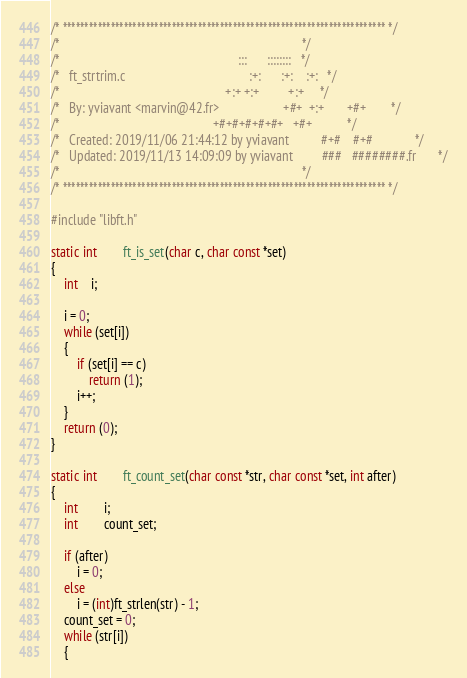<code> <loc_0><loc_0><loc_500><loc_500><_C_>/* ************************************************************************** */
/*                                                                            */
/*                                                        :::      ::::::::   */
/*   ft_strtrim.c                                       :+:      :+:    :+:   */
/*                                                    +:+ +:+         +:+     */
/*   By: yviavant <marvin@42.fr>                    +#+  +:+       +#+        */
/*                                                +#+#+#+#+#+   +#+           */
/*   Created: 2019/11/06 21:44:12 by yviavant          #+#    #+#             */
/*   Updated: 2019/11/13 14:09:09 by yviavant         ###   ########.fr       */
/*                                                                            */
/* ************************************************************************** */

#include "libft.h"

static int		ft_is_set(char c, char const *set)
{
	int	i;

	i = 0;
	while (set[i])
	{
		if (set[i] == c)
			return (1);
		i++;
	}
	return (0);
}

static int		ft_count_set(char const *str, char const *set, int after)
{
	int		i;
	int		count_set;

	if (after)
		i = 0;
	else
		i = (int)ft_strlen(str) - 1;
	count_set = 0;
	while (str[i])
	{</code> 